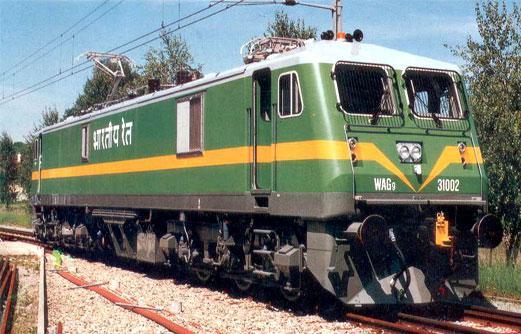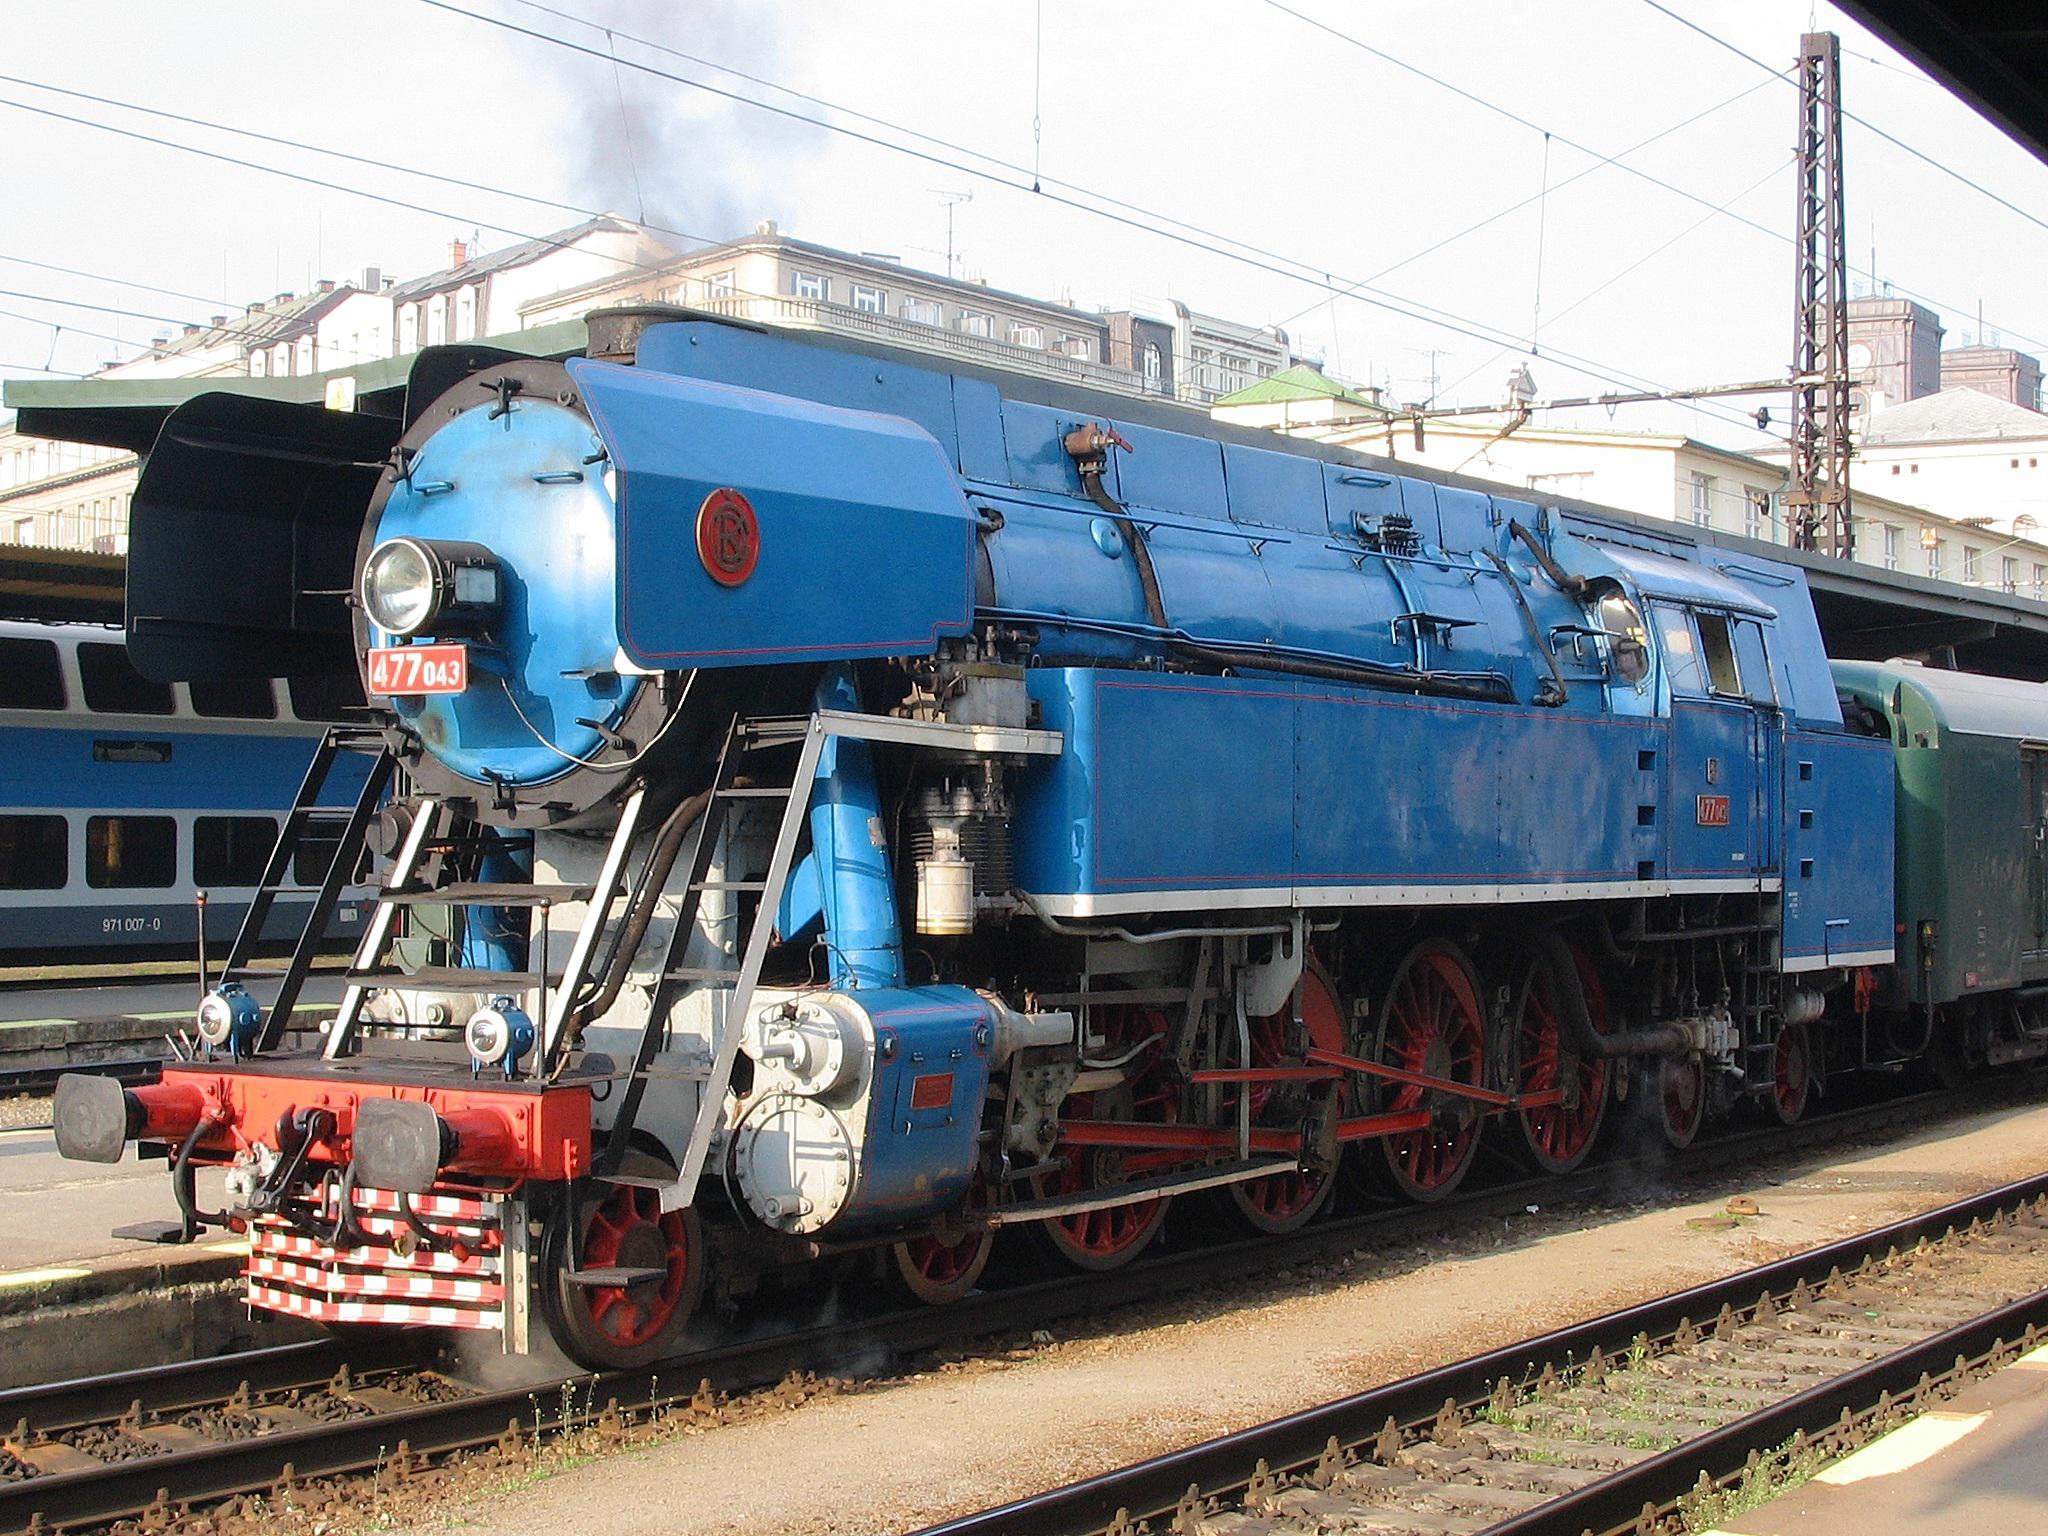The first image is the image on the left, the second image is the image on the right. Evaluate the accuracy of this statement regarding the images: "Both trains are facing left". Is it true? Answer yes or no. No. 